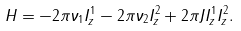Convert formula to latex. <formula><loc_0><loc_0><loc_500><loc_500>H = - 2 \pi \nu _ { 1 } I _ { z } ^ { 1 } - 2 \pi \nu _ { 2 } I _ { z } ^ { 2 } + 2 \pi J I _ { z } ^ { 1 } I _ { z } ^ { 2 } .</formula> 